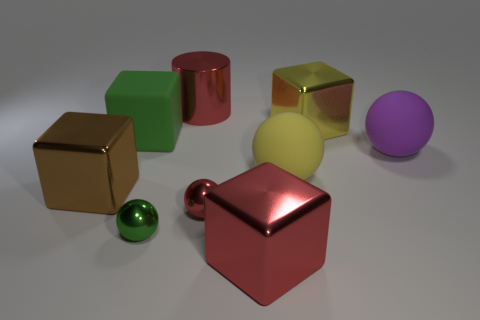Subtract all green cubes. How many cubes are left? 3 Subtract all large yellow balls. How many balls are left? 3 Subtract 1 cylinders. How many cylinders are left? 0 Subtract all blue spheres. How many cyan cubes are left? 0 Add 4 tiny objects. How many tiny objects are left? 6 Add 7 green rubber cylinders. How many green rubber cylinders exist? 7 Add 1 big red shiny cubes. How many objects exist? 10 Subtract 0 cyan cubes. How many objects are left? 9 Subtract all cylinders. How many objects are left? 8 Subtract all cyan spheres. Subtract all brown cubes. How many spheres are left? 4 